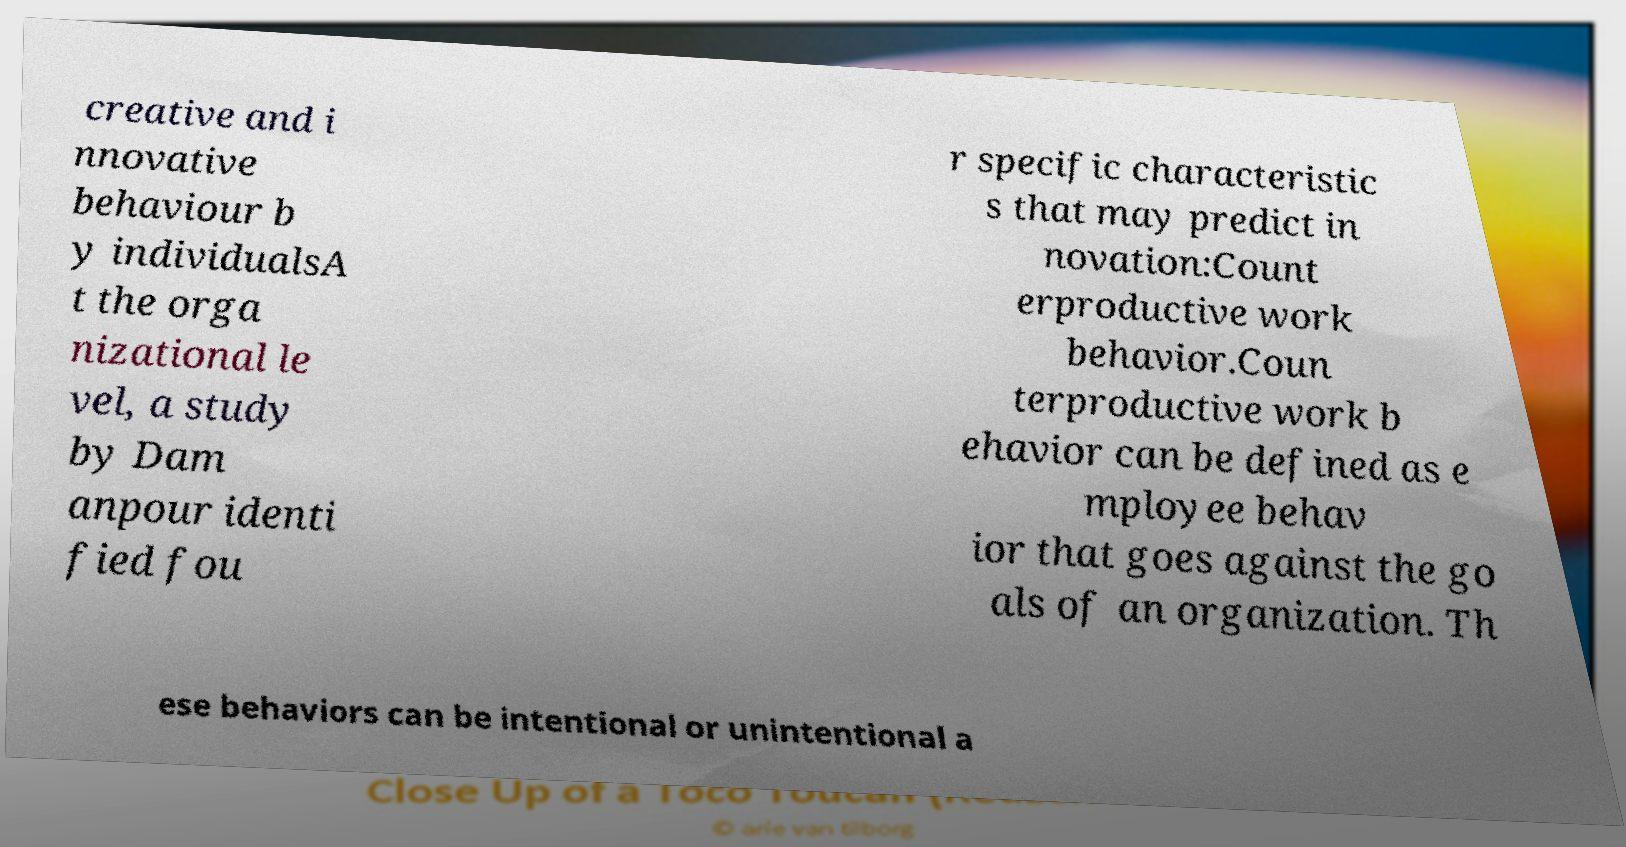Can you read and provide the text displayed in the image?This photo seems to have some interesting text. Can you extract and type it out for me? creative and i nnovative behaviour b y individualsA t the orga nizational le vel, a study by Dam anpour identi fied fou r specific characteristic s that may predict in novation:Count erproductive work behavior.Coun terproductive work b ehavior can be defined as e mployee behav ior that goes against the go als of an organization. Th ese behaviors can be intentional or unintentional a 